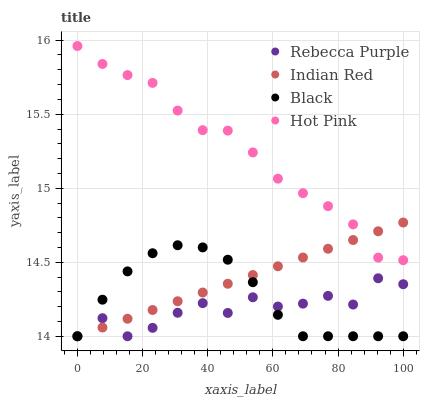Does Rebecca Purple have the minimum area under the curve?
Answer yes or no. Yes. Does Hot Pink have the maximum area under the curve?
Answer yes or no. Yes. Does Black have the minimum area under the curve?
Answer yes or no. No. Does Black have the maximum area under the curve?
Answer yes or no. No. Is Indian Red the smoothest?
Answer yes or no. Yes. Is Rebecca Purple the roughest?
Answer yes or no. Yes. Is Black the smoothest?
Answer yes or no. No. Is Black the roughest?
Answer yes or no. No. Does Black have the lowest value?
Answer yes or no. Yes. Does Hot Pink have the highest value?
Answer yes or no. Yes. Does Black have the highest value?
Answer yes or no. No. Is Black less than Hot Pink?
Answer yes or no. Yes. Is Hot Pink greater than Black?
Answer yes or no. Yes. Does Indian Red intersect Black?
Answer yes or no. Yes. Is Indian Red less than Black?
Answer yes or no. No. Is Indian Red greater than Black?
Answer yes or no. No. Does Black intersect Hot Pink?
Answer yes or no. No. 